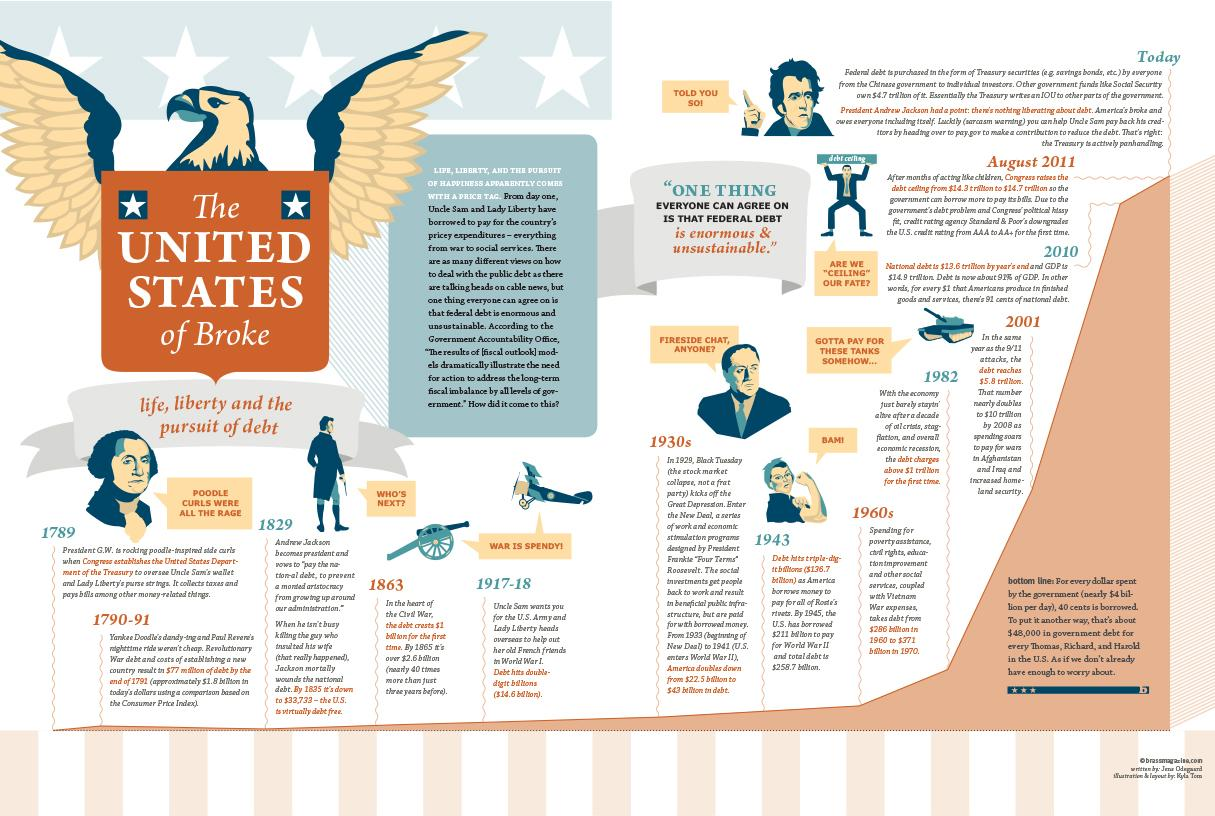Identify some key points in this picture. In 1863, the debts crossed $1 billion. The debts of the US crossed triple digit numbers in 1943. During the years 1917-1918, the debts of the United States reached double-digit numbers for the first time. 